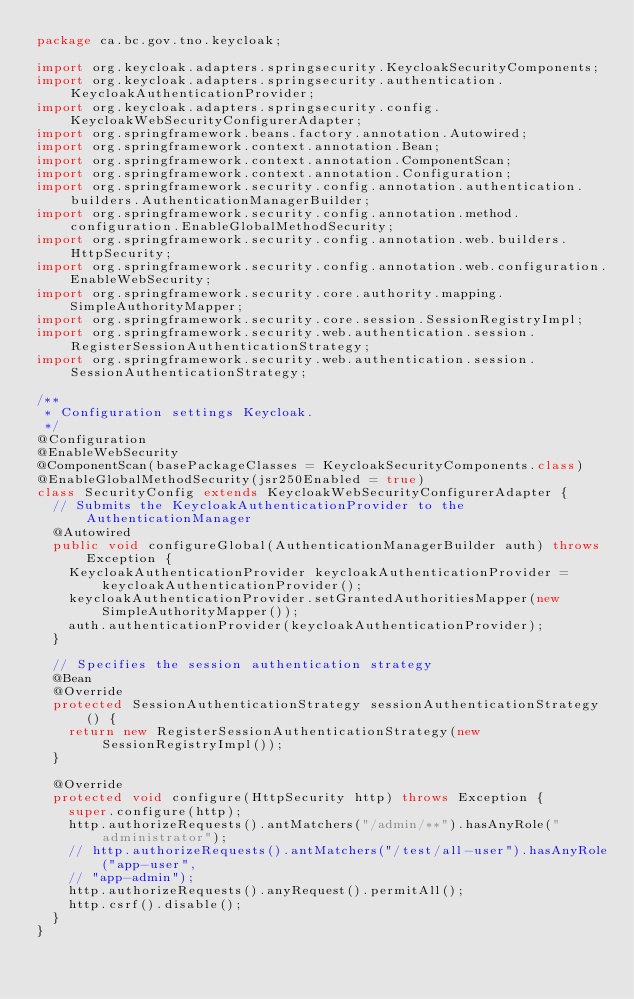Convert code to text. <code><loc_0><loc_0><loc_500><loc_500><_Java_>package ca.bc.gov.tno.keycloak;

import org.keycloak.adapters.springsecurity.KeycloakSecurityComponents;
import org.keycloak.adapters.springsecurity.authentication.KeycloakAuthenticationProvider;
import org.keycloak.adapters.springsecurity.config.KeycloakWebSecurityConfigurerAdapter;
import org.springframework.beans.factory.annotation.Autowired;
import org.springframework.context.annotation.Bean;
import org.springframework.context.annotation.ComponentScan;
import org.springframework.context.annotation.Configuration;
import org.springframework.security.config.annotation.authentication.builders.AuthenticationManagerBuilder;
import org.springframework.security.config.annotation.method.configuration.EnableGlobalMethodSecurity;
import org.springframework.security.config.annotation.web.builders.HttpSecurity;
import org.springframework.security.config.annotation.web.configuration.EnableWebSecurity;
import org.springframework.security.core.authority.mapping.SimpleAuthorityMapper;
import org.springframework.security.core.session.SessionRegistryImpl;
import org.springframework.security.web.authentication.session.RegisterSessionAuthenticationStrategy;
import org.springframework.security.web.authentication.session.SessionAuthenticationStrategy;

/**
 * Configuration settings Keycloak.
 */
@Configuration
@EnableWebSecurity
@ComponentScan(basePackageClasses = KeycloakSecurityComponents.class)
@EnableGlobalMethodSecurity(jsr250Enabled = true)
class SecurityConfig extends KeycloakWebSecurityConfigurerAdapter {
  // Submits the KeycloakAuthenticationProvider to the AuthenticationManager
  @Autowired
  public void configureGlobal(AuthenticationManagerBuilder auth) throws Exception {
    KeycloakAuthenticationProvider keycloakAuthenticationProvider = keycloakAuthenticationProvider();
    keycloakAuthenticationProvider.setGrantedAuthoritiesMapper(new SimpleAuthorityMapper());
    auth.authenticationProvider(keycloakAuthenticationProvider);
  }

  // Specifies the session authentication strategy
  @Bean
  @Override
  protected SessionAuthenticationStrategy sessionAuthenticationStrategy() {
    return new RegisterSessionAuthenticationStrategy(new SessionRegistryImpl());
  }

  @Override
  protected void configure(HttpSecurity http) throws Exception {
    super.configure(http);
    http.authorizeRequests().antMatchers("/admin/**").hasAnyRole("administrator");
    // http.authorizeRequests().antMatchers("/test/all-user").hasAnyRole("app-user",
    // "app-admin");
    http.authorizeRequests().anyRequest().permitAll();
    http.csrf().disable();
  }
}</code> 